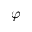Convert formula to latex. <formula><loc_0><loc_0><loc_500><loc_500>\varphi</formula> 